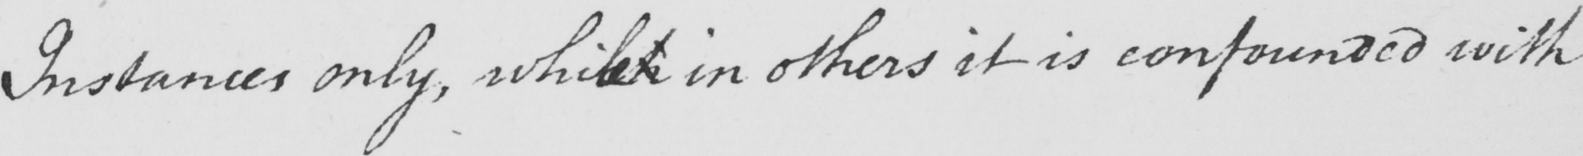What text is written in this handwritten line? Instances only , whilst in others it is confounded with 